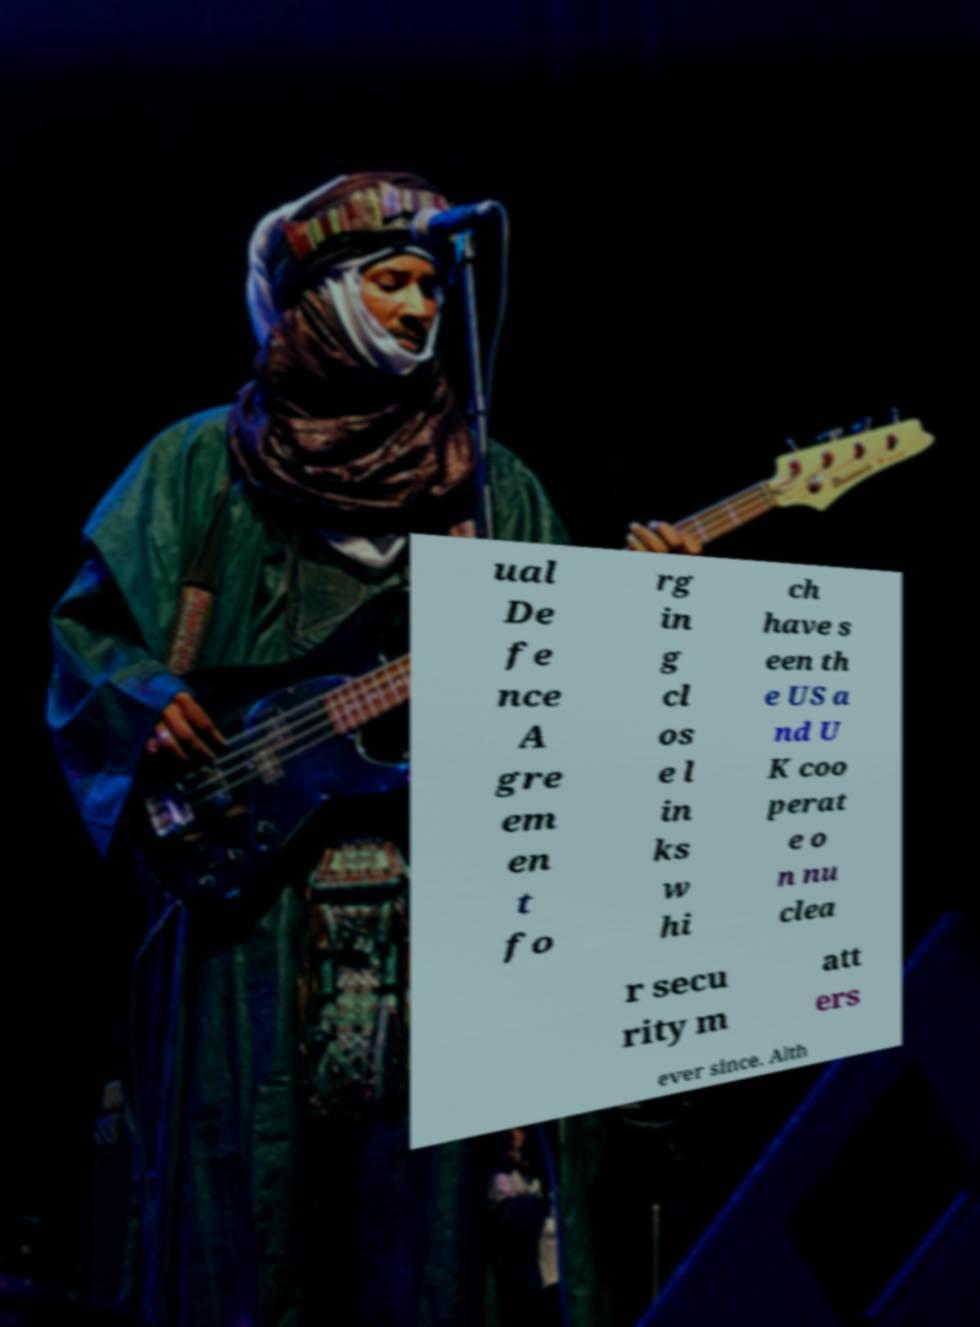I need the written content from this picture converted into text. Can you do that? ual De fe nce A gre em en t fo rg in g cl os e l in ks w hi ch have s een th e US a nd U K coo perat e o n nu clea r secu rity m att ers ever since. Alth 